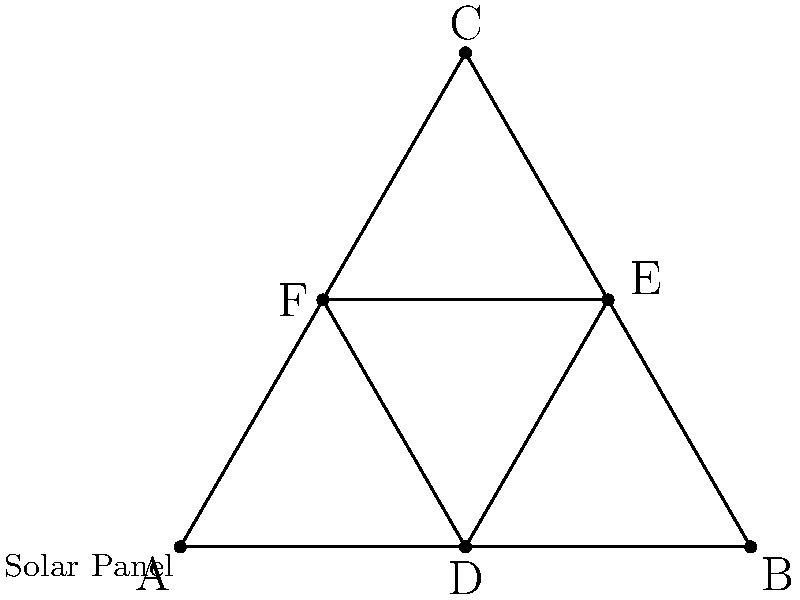At the nearby solar farm, you notice a triangular arrangement of solar panels with smaller triangles inside. Eli Heredia mentions that this arrangement has interesting symmetrical properties. How many rotational symmetries does this solar panel arrangement have? Let's approach this step-by-step:

1. First, we need to identify the shape: it's a triangle with another triangle inside it, formed by connecting the midpoints of the outer triangle's sides.

2. In group theory, we consider the rotational symmetries of a shape. These are rotations that leave the shape looking identical to its starting position.

3. For a triangle, there are three rotational symmetries:
   a) Rotation by 0° (identity)
   b) Rotation by 120° clockwise
   c) Rotation by 240° clockwise (or 120° counterclockwise)

4. The inner triangle doesn't change the rotational symmetries because it's formed by the midpoints of the outer triangle's sides. It rotates along with the outer triangle.

5. Any rotation other than these three would result in a different arrangement, thus not preserving symmetry.

Therefore, this solar panel arrangement has 3 rotational symmetries.
Answer: 3 